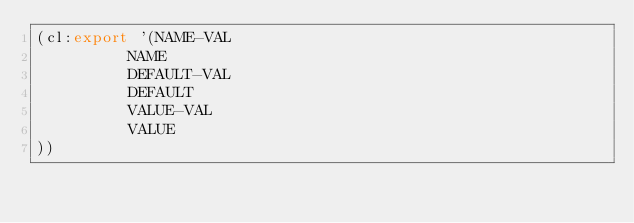<code> <loc_0><loc_0><loc_500><loc_500><_Lisp_>(cl:export '(NAME-VAL
          NAME
          DEFAULT-VAL
          DEFAULT
          VALUE-VAL
          VALUE
))</code> 